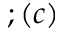Convert formula to latex. <formula><loc_0><loc_0><loc_500><loc_500>; ( c )</formula> 